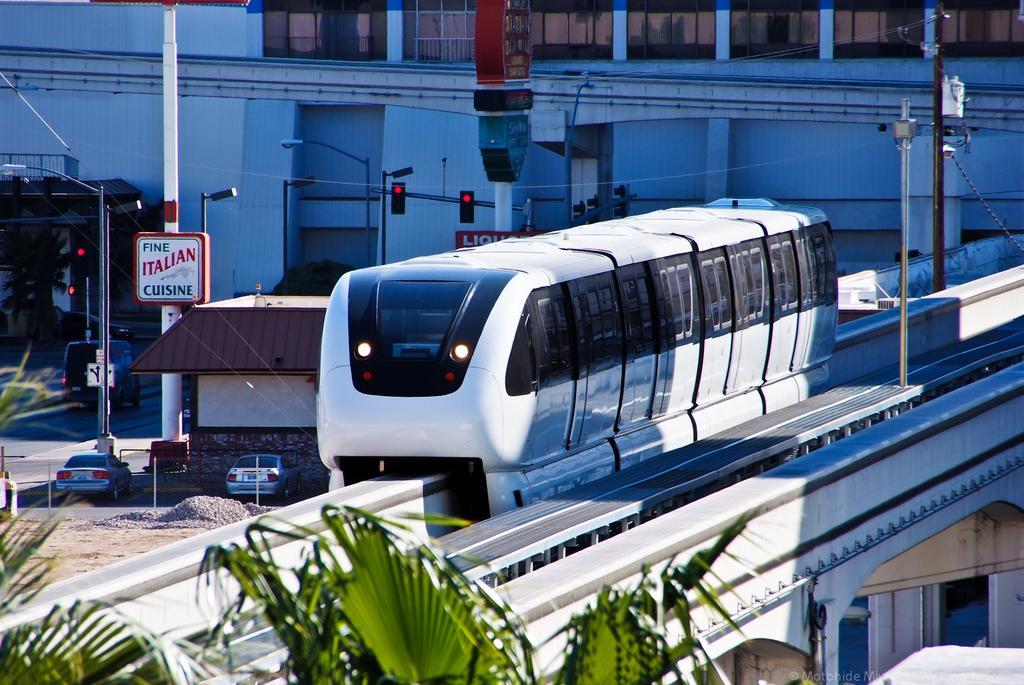Describe this image in one or two sentences. In this image there is a metro train under the metro train there is a house, near the house there is a road on that road there are light poles and signal poles, cars are parked to a side, in the background there is a big building. 